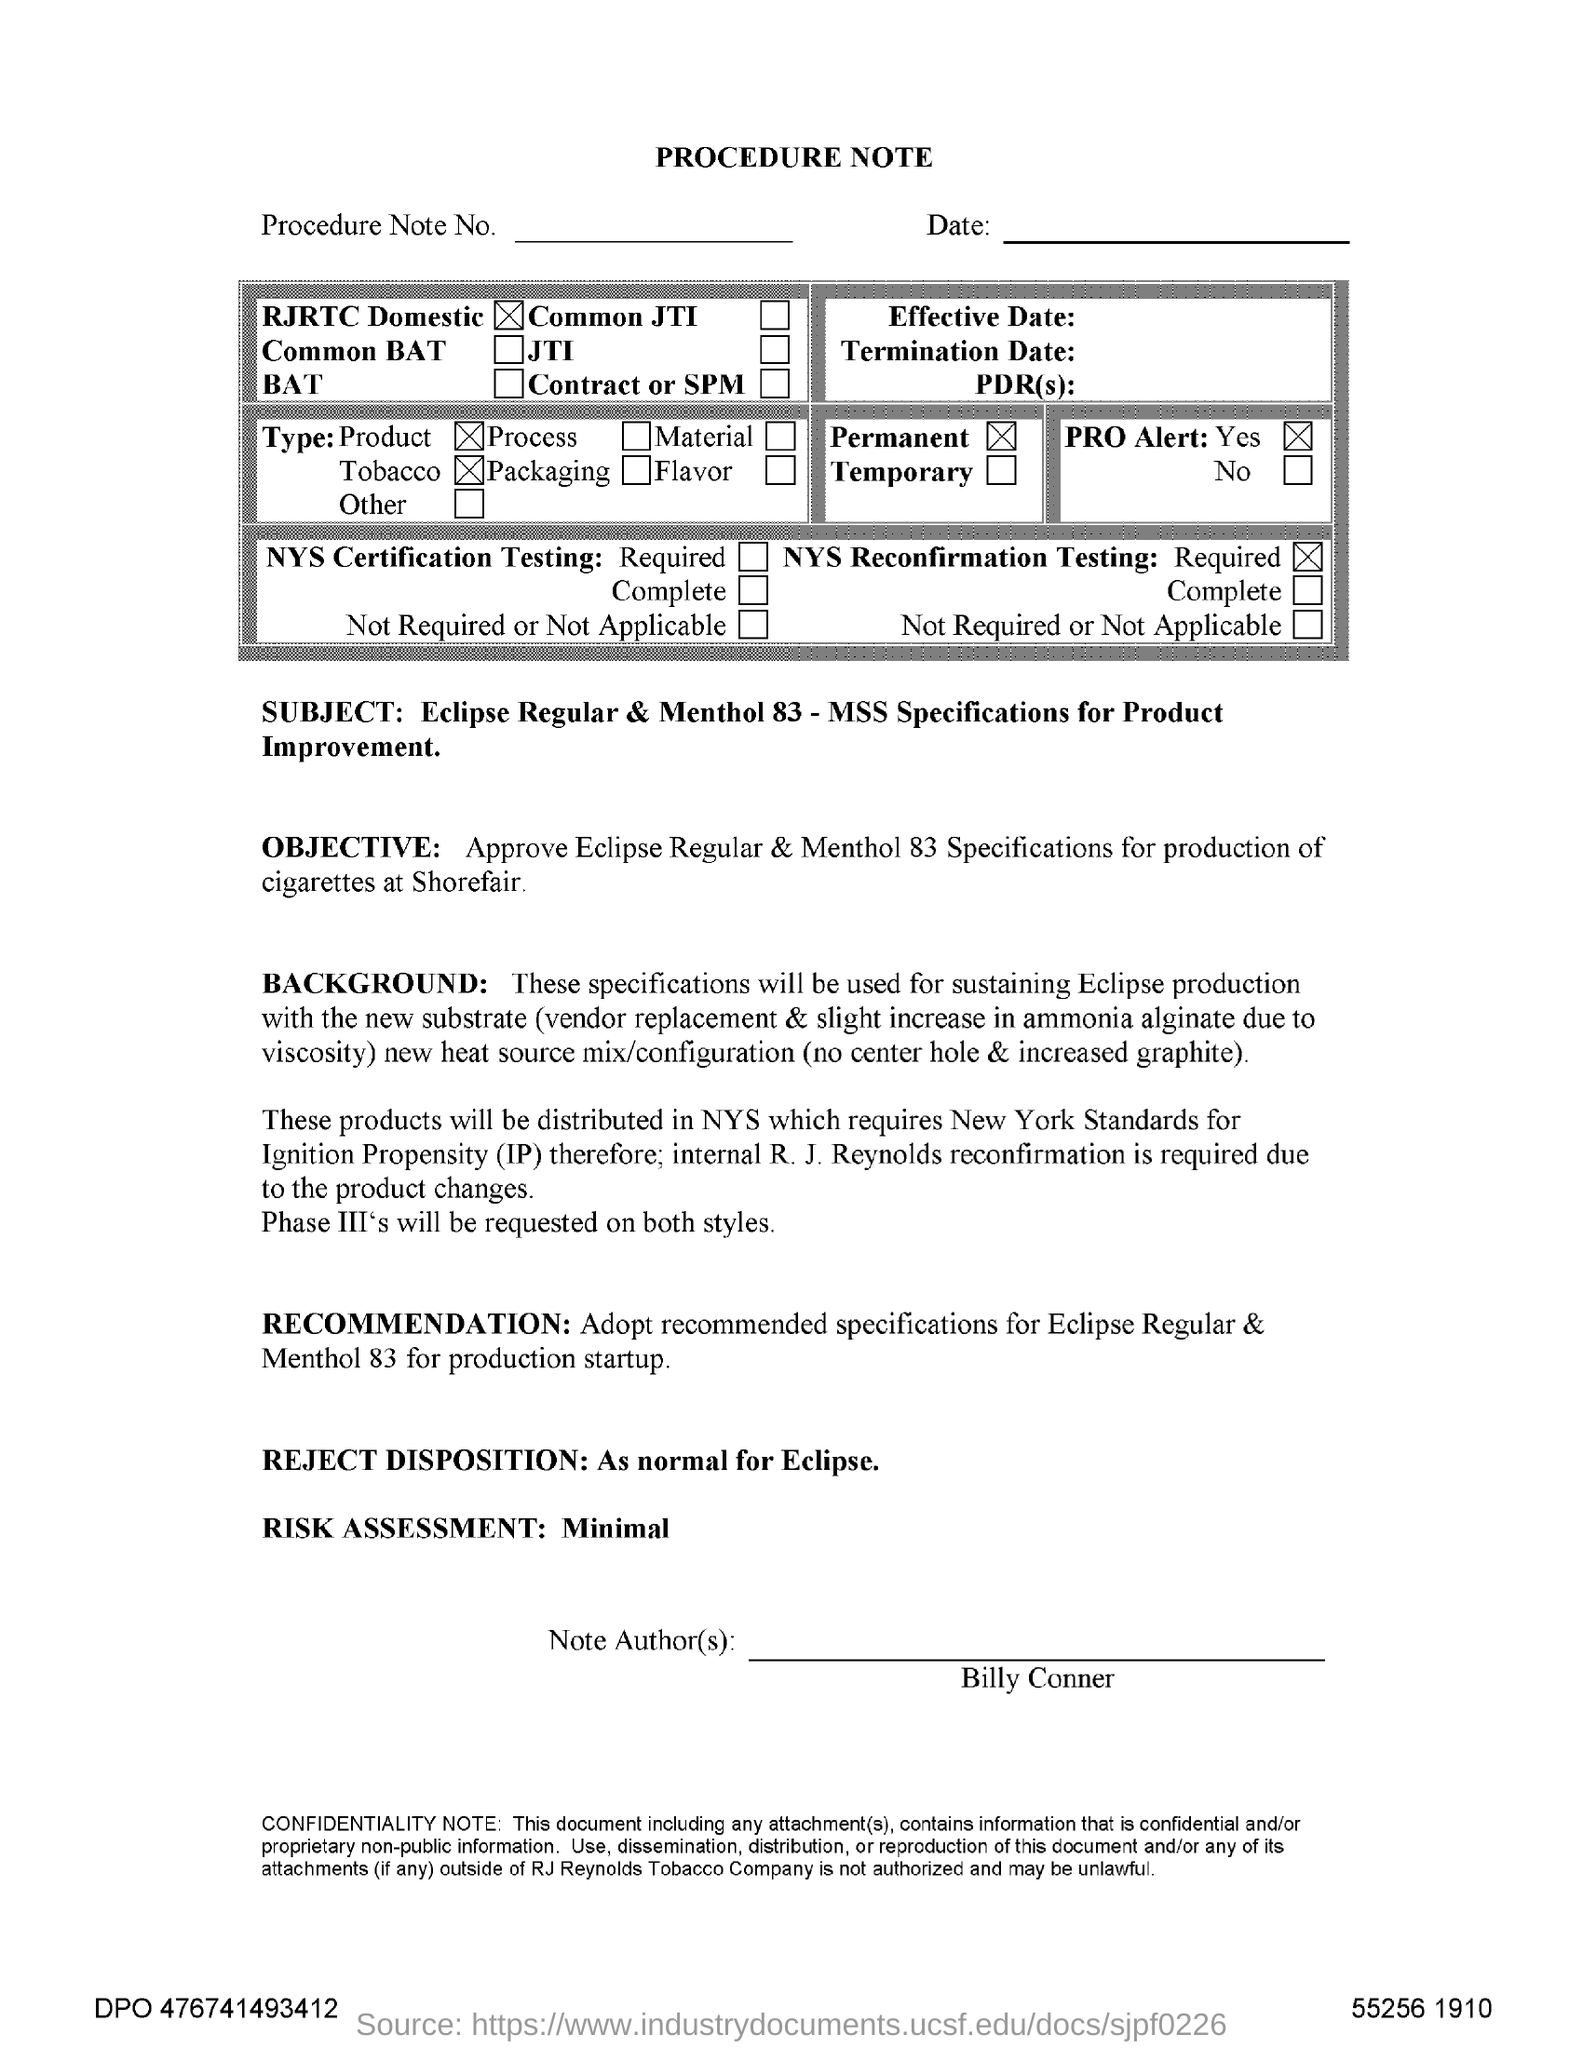What is the reject disposition?
Make the answer very short. AS NORMAL FOR ECLIPSE. What is the risk assessment?
Offer a terse response. Minimal. Who is the Note Author?
Keep it short and to the point. BILLY CONNER. 